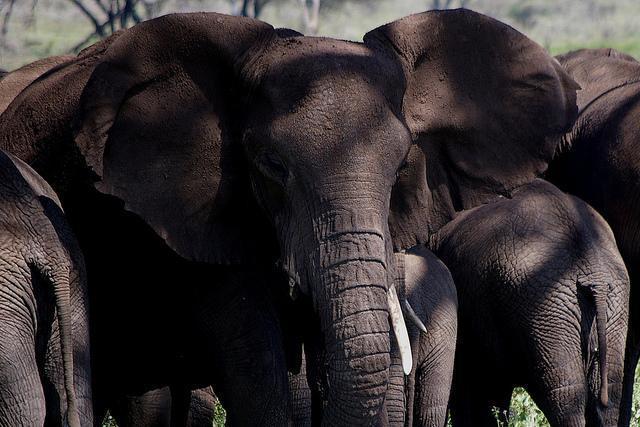How many elephant tusk are in this image?
Give a very brief answer. 1. How many elephants are in this scene?
Give a very brief answer. 5. How many elephants?
Give a very brief answer. 5. How many elephants are in this picture?
Give a very brief answer. 5. How many elephants can be seen?
Give a very brief answer. 5. How many people are standing next to each other?
Give a very brief answer. 0. 